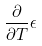<formula> <loc_0><loc_0><loc_500><loc_500>\frac { \partial } { \partial T } \epsilon</formula> 